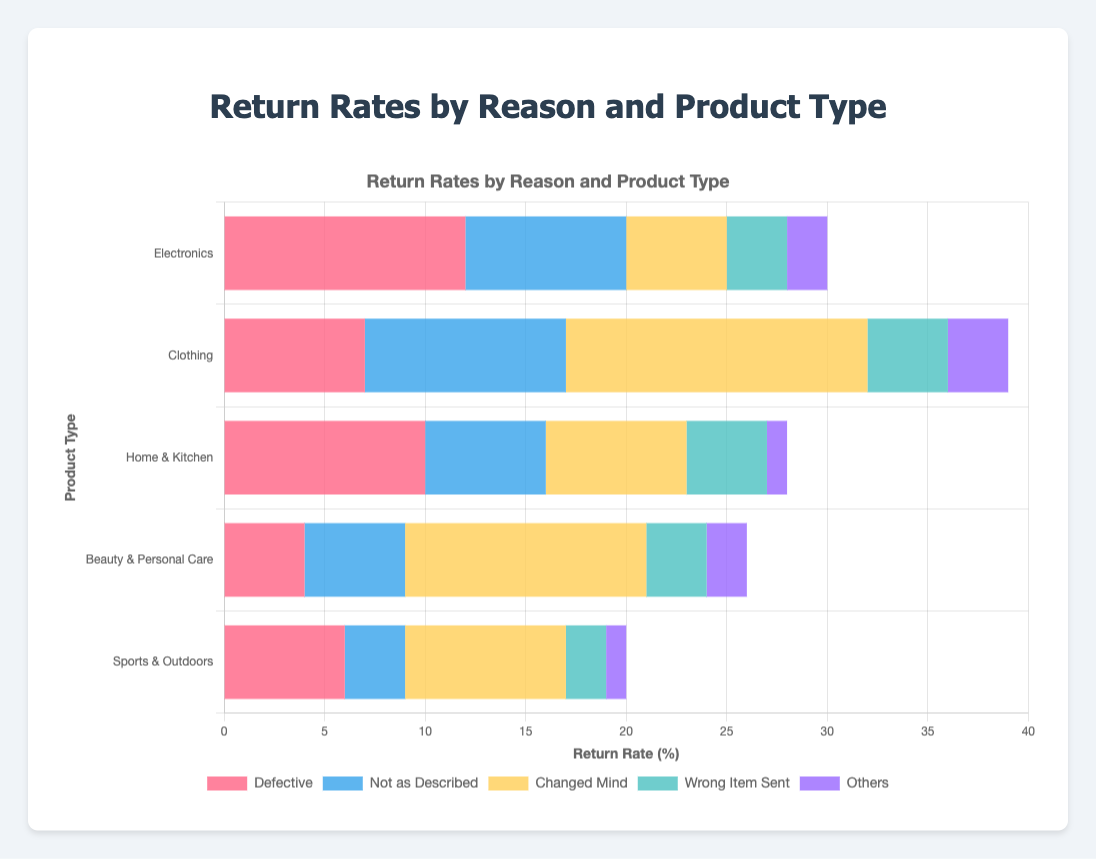What is the most common return reason for Electronics? To determine the most common return reason for Electronics, we look for the highest value among the return reasons for Electronics. In the data, "Defective" has a value of 12, which is the highest number.
Answer: Defective Which product type has the highest rate of "Changed Mind" returns? Compare the values of "Changed Mind" returns across all product types. Clothing, with a value of 15, has the highest rate of "Changed Mind" returns.
Answer: Clothing What is the total return rate for "Home & Kitchen" products? To get the total return rate for "Home & Kitchen" products, sum the values of all return reasons for this product type: 10 (Defective) + 6 (Not as Described) + 7 (Changed Mind) + 4 (Wrong Item Sent) + 1 (Others) = 28.
Answer: 28 How does the rate of "Wrong Item Sent" returns for "Clothing" compare to "Beauty & Personal Care"? Compare the values of the "Wrong Item Sent" return reason for Clothing (4) and Beauty & Personal Care (3). Clothing has a higher rate of "Wrong Item Sent" returns.
Answer: Clothing What is the sum of returns for "Defective" across all product types? Add up the values for "Defective" returns across all product types: 
- Electronics: 12 
- Clothing: 7 
- Home & Kitchen: 10 
- Beauty & Personal Care: 4 
- Sports & Outdoors: 6 
Sum = 12 + 7 + 10 + 4 + 6 = 39.
Answer: 39 What is the average number of "Not as Described" returns across all product types? Calculate the average of "Not as Described" returns: 
Sum of returns = 8 (Electronics) + 10 (Clothing) + 6 (Home & Kitchen) + 5 (Beauty & Personal Care) + 3 (Sports & Outdoors) = 32. 
Number of product types = 5 
Average = 32 / 5 = 6.4.
Answer: 6.4 